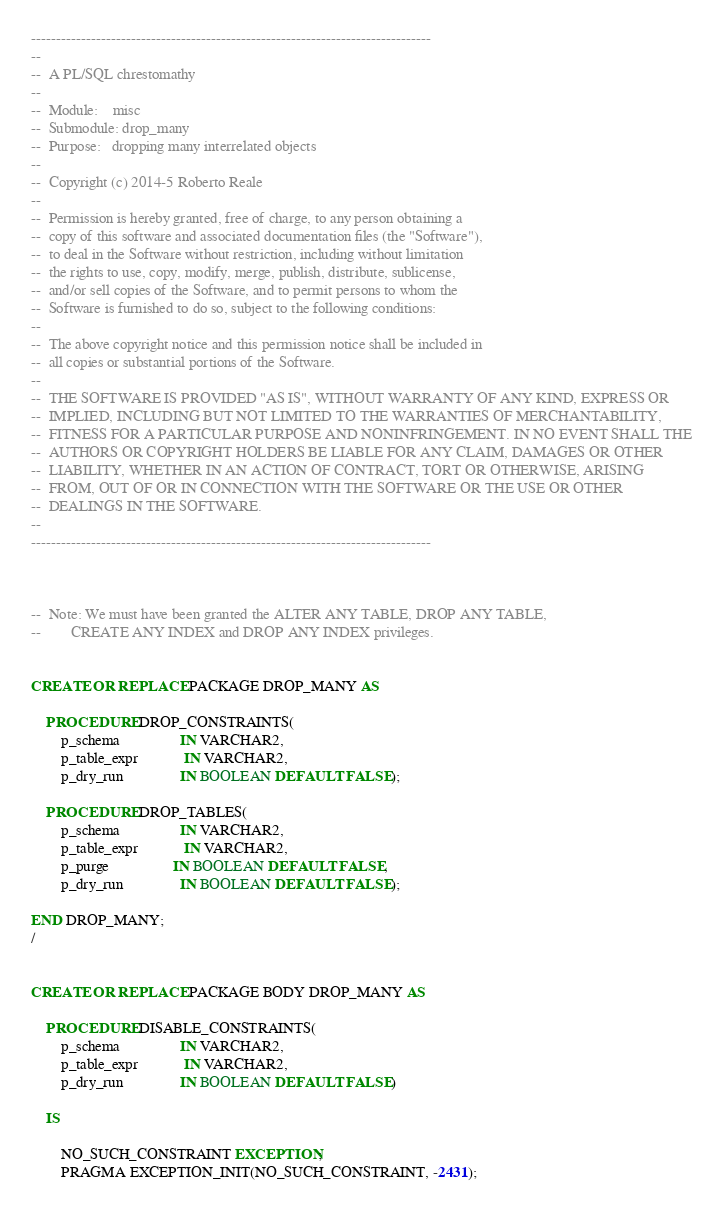Convert code to text. <code><loc_0><loc_0><loc_500><loc_500><_SQL_>--------------------------------------------------------------------------------
--
--  A PL/SQL chrestomathy
-- 
--  Module:    misc
--  Submodule: drop_many
--  Purpose:   dropping many interrelated objects
--
--  Copyright (c) 2014-5 Roberto Reale
--  
--  Permission is hereby granted, free of charge, to any person obtaining a
--  copy of this software and associated documentation files (the "Software"),
--  to deal in the Software without restriction, including without limitation
--  the rights to use, copy, modify, merge, publish, distribute, sublicense,
--  and/or sell copies of the Software, and to permit persons to whom the
--  Software is furnished to do so, subject to the following conditions:
--  
--  The above copyright notice and this permission notice shall be included in
--  all copies or substantial portions of the Software.
--  
--  THE SOFTWARE IS PROVIDED "AS IS", WITHOUT WARRANTY OF ANY KIND, EXPRESS OR
--  IMPLIED, INCLUDING BUT NOT LIMITED TO THE WARRANTIES OF MERCHANTABILITY,
--  FITNESS FOR A PARTICULAR PURPOSE AND NONINFRINGEMENT. IN NO EVENT SHALL THE
--  AUTHORS OR COPYRIGHT HOLDERS BE LIABLE FOR ANY CLAIM, DAMAGES OR OTHER
--  LIABILITY, WHETHER IN AN ACTION OF CONTRACT, TORT OR OTHERWISE, ARISING
--  FROM, OUT OF OR IN CONNECTION WITH THE SOFTWARE OR THE USE OR OTHER
--  DEALINGS IN THE SOFTWARE.
-- 
--------------------------------------------------------------------------------



--  Note: We must have been granted the ALTER ANY TABLE, DROP ANY TABLE,
--        CREATE ANY INDEX and DROP ANY INDEX privileges.


CREATE OR REPLACE PACKAGE DROP_MANY AS

    PROCEDURE DROP_CONSTRAINTS(
        p_schema                IN VARCHAR2,
        p_table_expr            IN VARCHAR2,
        p_dry_run               IN BOOLEAN DEFAULT FALSE);

    PROCEDURE DROP_TABLES(
        p_schema                IN VARCHAR2,
        p_table_expr            IN VARCHAR2,
        p_purge                 IN BOOLEAN DEFAULT FALSE,
        p_dry_run               IN BOOLEAN DEFAULT FALSE);
    
END DROP_MANY;
/


CREATE OR REPLACE PACKAGE BODY DROP_MANY AS

    PROCEDURE DISABLE_CONSTRAINTS(
        p_schema                IN VARCHAR2,
        p_table_expr            IN VARCHAR2,
        p_dry_run               IN BOOLEAN DEFAULT FALSE)

    IS

        NO_SUCH_CONSTRAINT EXCEPTION;
        PRAGMA EXCEPTION_INIT(NO_SUCH_CONSTRAINT, -2431);
</code> 